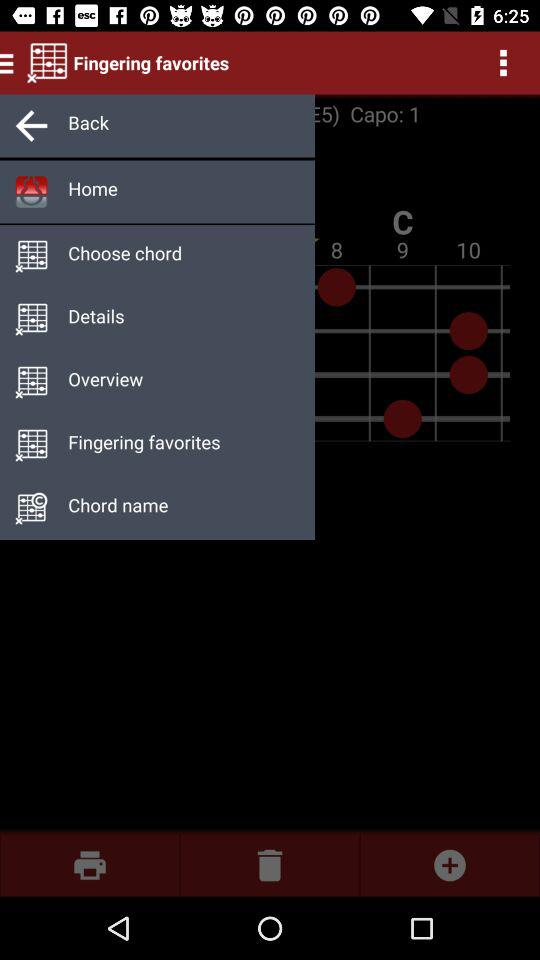Which fingerings are the favorites?
When the provided information is insufficient, respond with <no answer>. <no answer> 